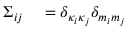<formula> <loc_0><loc_0><loc_500><loc_500>\begin{array} { r l } { \Sigma _ { i j } } & = \delta _ { \kappa _ { i } \kappa _ { j } } \delta _ { m _ { i } m _ { j } } } \end{array}</formula> 